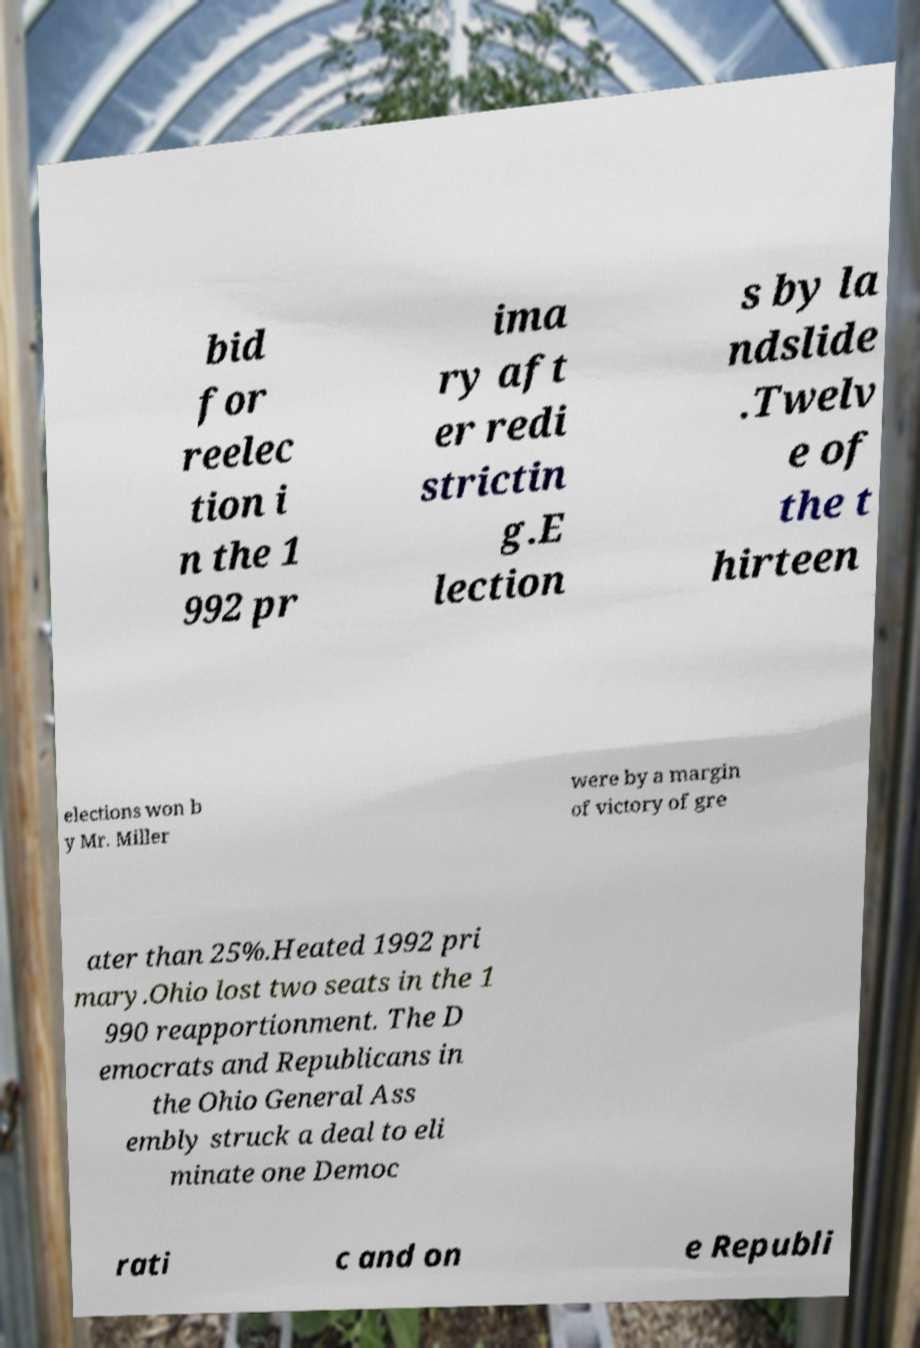Could you extract and type out the text from this image? bid for reelec tion i n the 1 992 pr ima ry aft er redi strictin g.E lection s by la ndslide .Twelv e of the t hirteen elections won b y Mr. Miller were by a margin of victory of gre ater than 25%.Heated 1992 pri mary.Ohio lost two seats in the 1 990 reapportionment. The D emocrats and Republicans in the Ohio General Ass embly struck a deal to eli minate one Democ rati c and on e Republi 